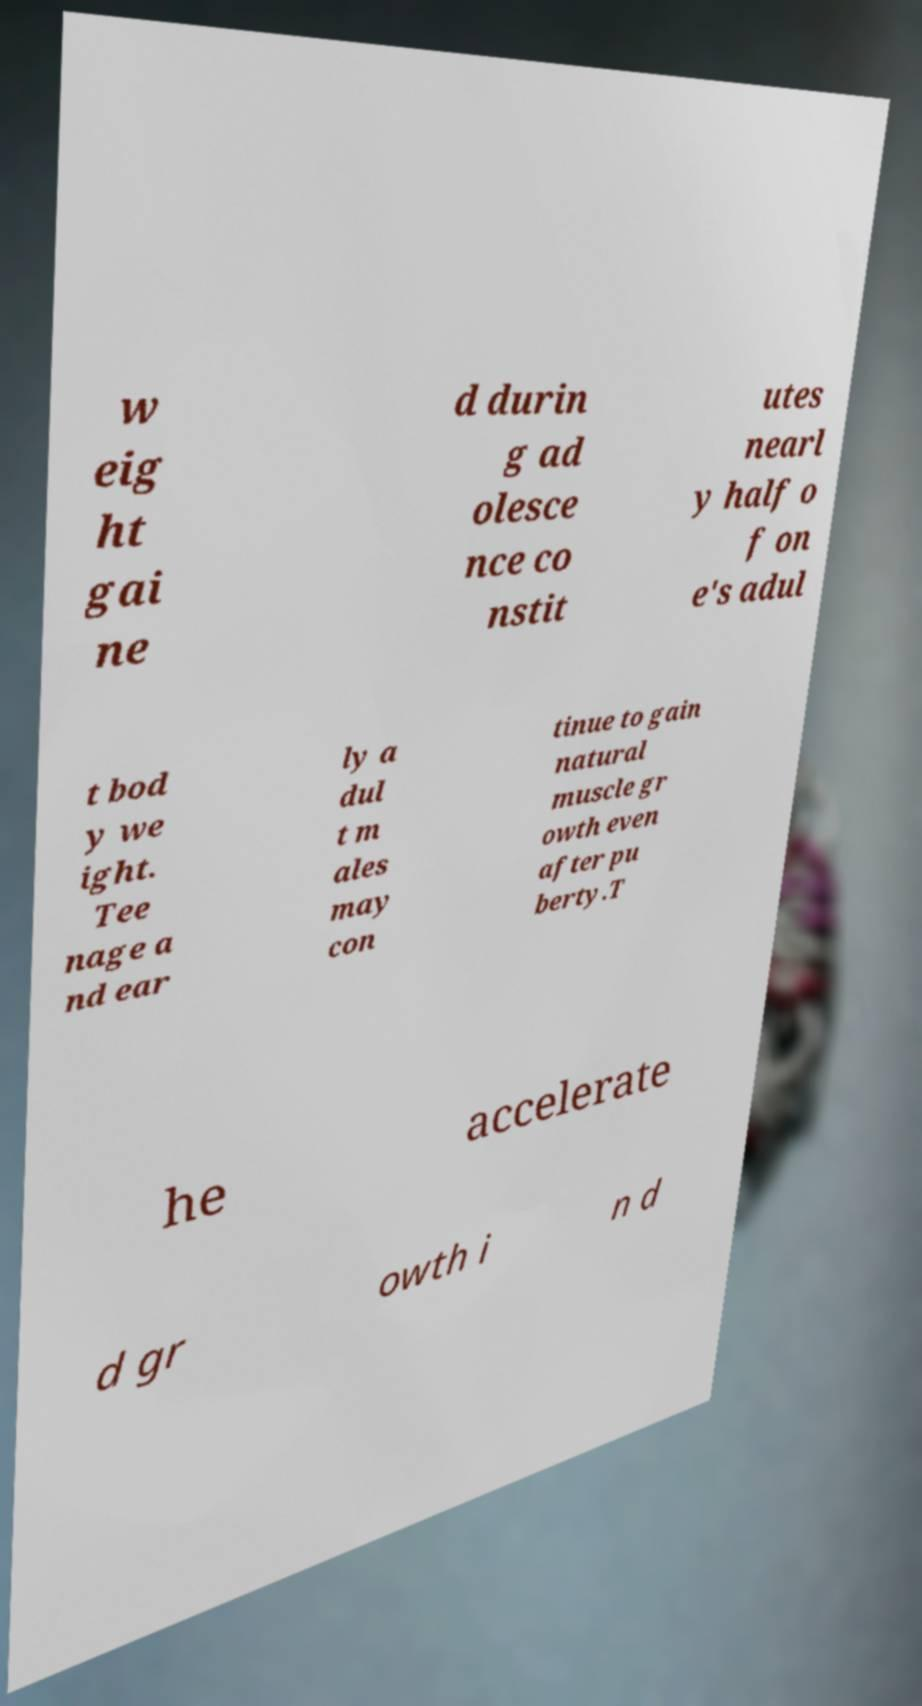There's text embedded in this image that I need extracted. Can you transcribe it verbatim? w eig ht gai ne d durin g ad olesce nce co nstit utes nearl y half o f on e's adul t bod y we ight. Tee nage a nd ear ly a dul t m ales may con tinue to gain natural muscle gr owth even after pu berty.T he accelerate d gr owth i n d 